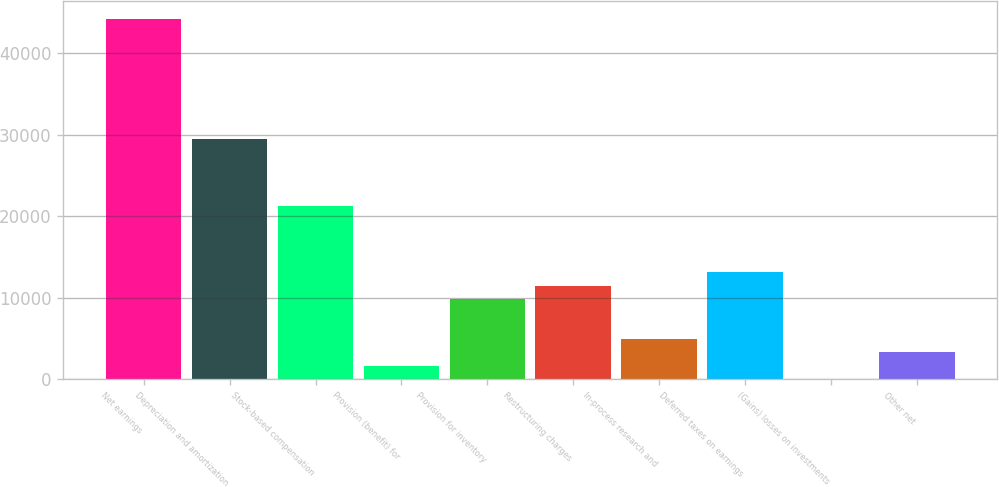Convert chart. <chart><loc_0><loc_0><loc_500><loc_500><bar_chart><fcel>Net earnings<fcel>Depreciation and amortization<fcel>Stock-based compensation<fcel>Provision (benefit) for<fcel>Provision for inventory<fcel>Restructuring charges<fcel>In-process research and<fcel>Deferred taxes on earnings<fcel>(Gains) losses on investments<fcel>Other net<nl><fcel>44256.2<fcel>29508.8<fcel>21315.8<fcel>1652.6<fcel>9845.6<fcel>11484.2<fcel>4929.8<fcel>13122.8<fcel>14<fcel>3291.2<nl></chart> 